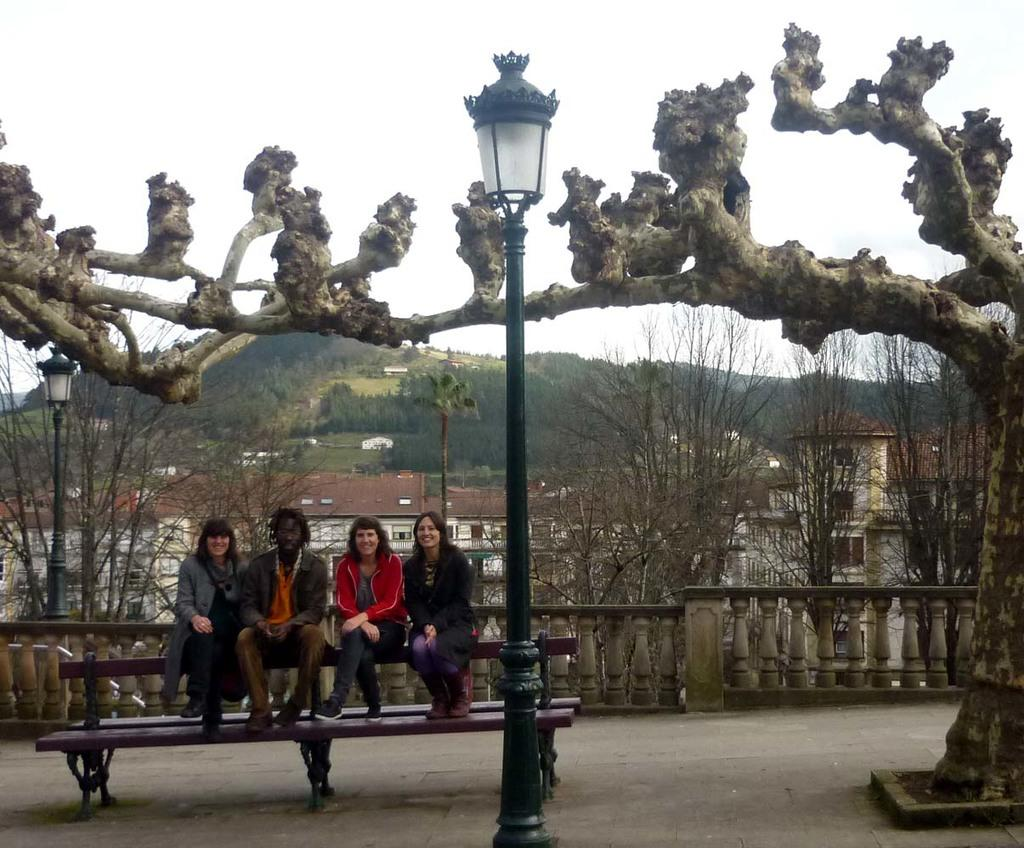How many people are sitting on the bench in the image? There are four people sitting on a bench in the image. What is the source of light in the image? There is a street light in the image. What can be seen in the background of the image? There are trees, buildings, a mountain, and the sky visible in the background of the image. What type of riddle can be solved by looking at the cactus in the image? There is no cactus present in the image, so no riddle can be solved by looking at a cactus. 